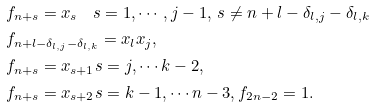<formula> <loc_0><loc_0><loc_500><loc_500>& \, f _ { n + s } = x _ { s } \quad s = 1 , \cdots , j - 1 , \, s \neq n + l - \delta _ { l , j } - \delta _ { l , k } \\ & \, f _ { n + l - \delta _ { l , j } - \delta _ { l , k } } = x _ { l } x _ { j } , \\ & \, f _ { n + s } = x _ { s + 1 } s = j , \cdots k - 2 , \\ & \, f _ { n + s } = x _ { s + 2 } s = k - 1 , \cdots n - 3 , f _ { 2 n - 2 } = 1 . \\</formula> 